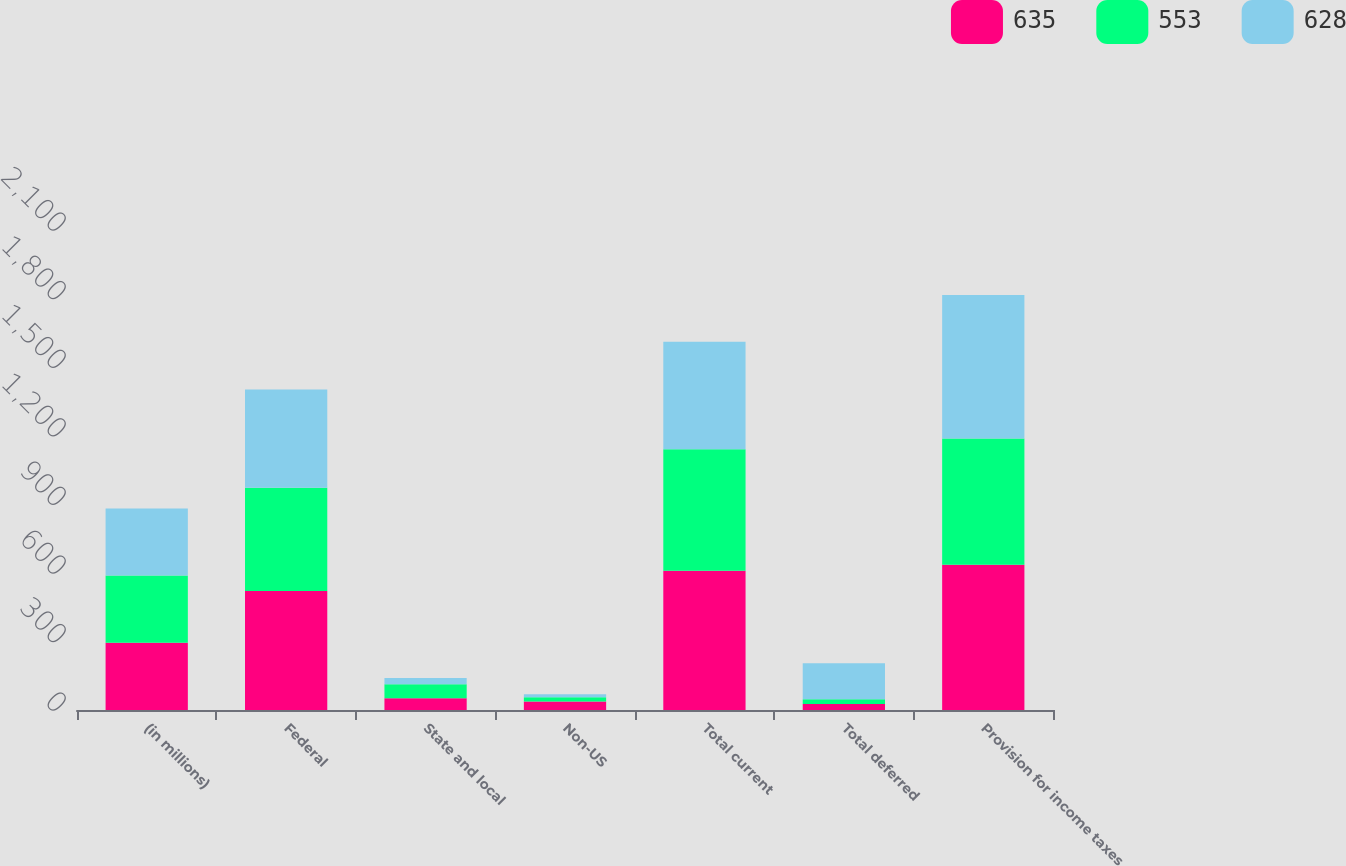<chart> <loc_0><loc_0><loc_500><loc_500><stacked_bar_chart><ecel><fcel>(in millions)<fcel>Federal<fcel>State and local<fcel>Non-US<fcel>Total current<fcel>Total deferred<fcel>Provision for income taxes<nl><fcel>635<fcel>294<fcel>521<fcel>51<fcel>37<fcel>609<fcel>26<fcel>635<nl><fcel>553<fcel>294<fcel>451<fcel>62<fcel>19<fcel>532<fcel>21<fcel>553<nl><fcel>628<fcel>294<fcel>430<fcel>27<fcel>13<fcel>470<fcel>158<fcel>628<nl></chart> 